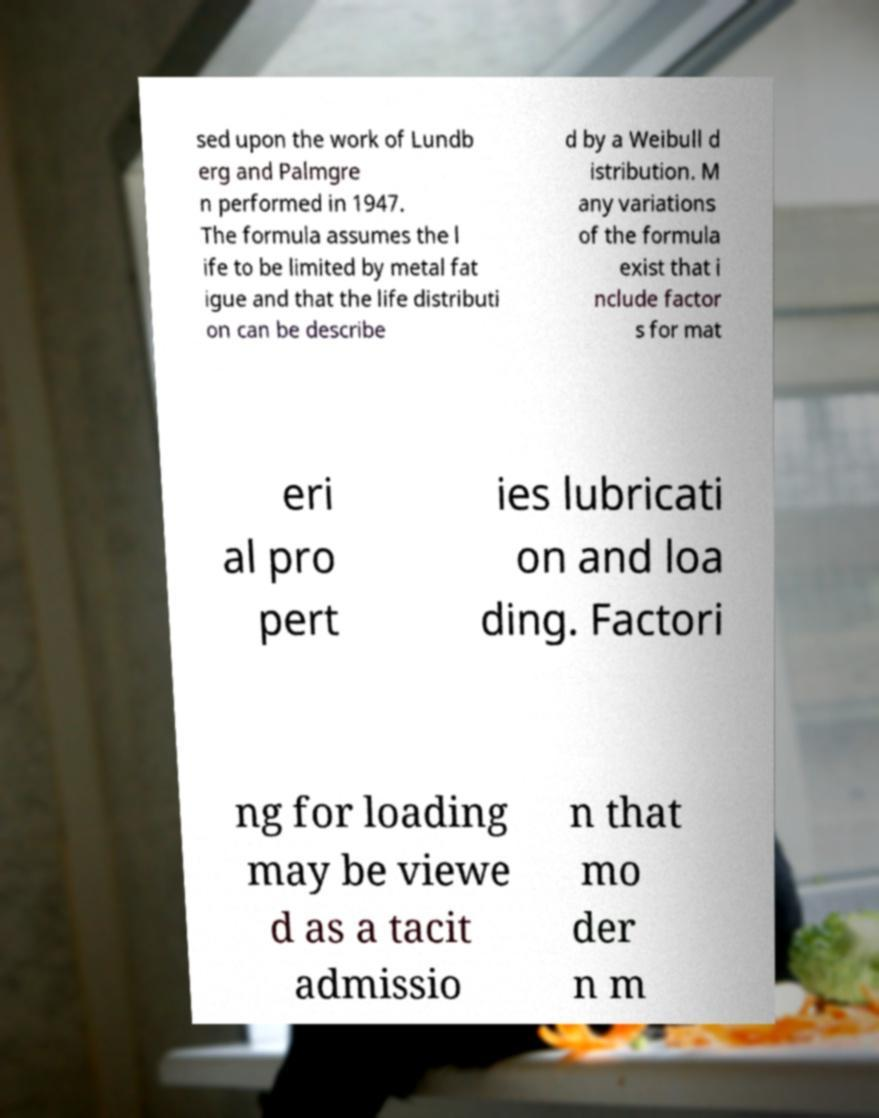Please identify and transcribe the text found in this image. sed upon the work of Lundb erg and Palmgre n performed in 1947. The formula assumes the l ife to be limited by metal fat igue and that the life distributi on can be describe d by a Weibull d istribution. M any variations of the formula exist that i nclude factor s for mat eri al pro pert ies lubricati on and loa ding. Factori ng for loading may be viewe d as a tacit admissio n that mo der n m 